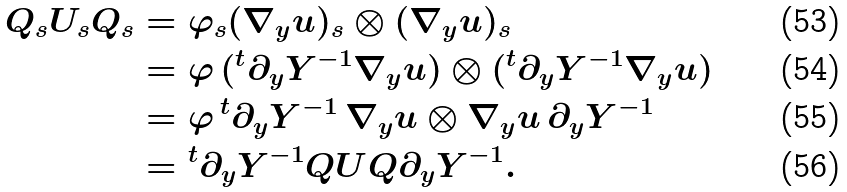Convert formula to latex. <formula><loc_0><loc_0><loc_500><loc_500>Q _ { s } U _ { s } Q _ { s } & = \varphi _ { s } ( \nabla _ { y } u ) _ { s } \otimes ( \nabla _ { y } u ) _ { s } \\ & = \varphi \, ( { ^ { t } \partial _ { y } Y ^ { - 1 } } \nabla _ { y } u ) \otimes ( { ^ { t } \partial _ { y } Y ^ { - 1 } } \nabla _ { y } u ) \\ & = \varphi \, { ^ { t } \partial _ { y } Y ^ { - 1 } } \, \nabla _ { y } u \otimes \nabla _ { y } u \, \partial _ { y } Y ^ { - 1 } \\ & = { ^ { t } \partial _ { y } Y ^ { - 1 } } Q U Q \partial _ { y } Y ^ { - 1 } .</formula> 